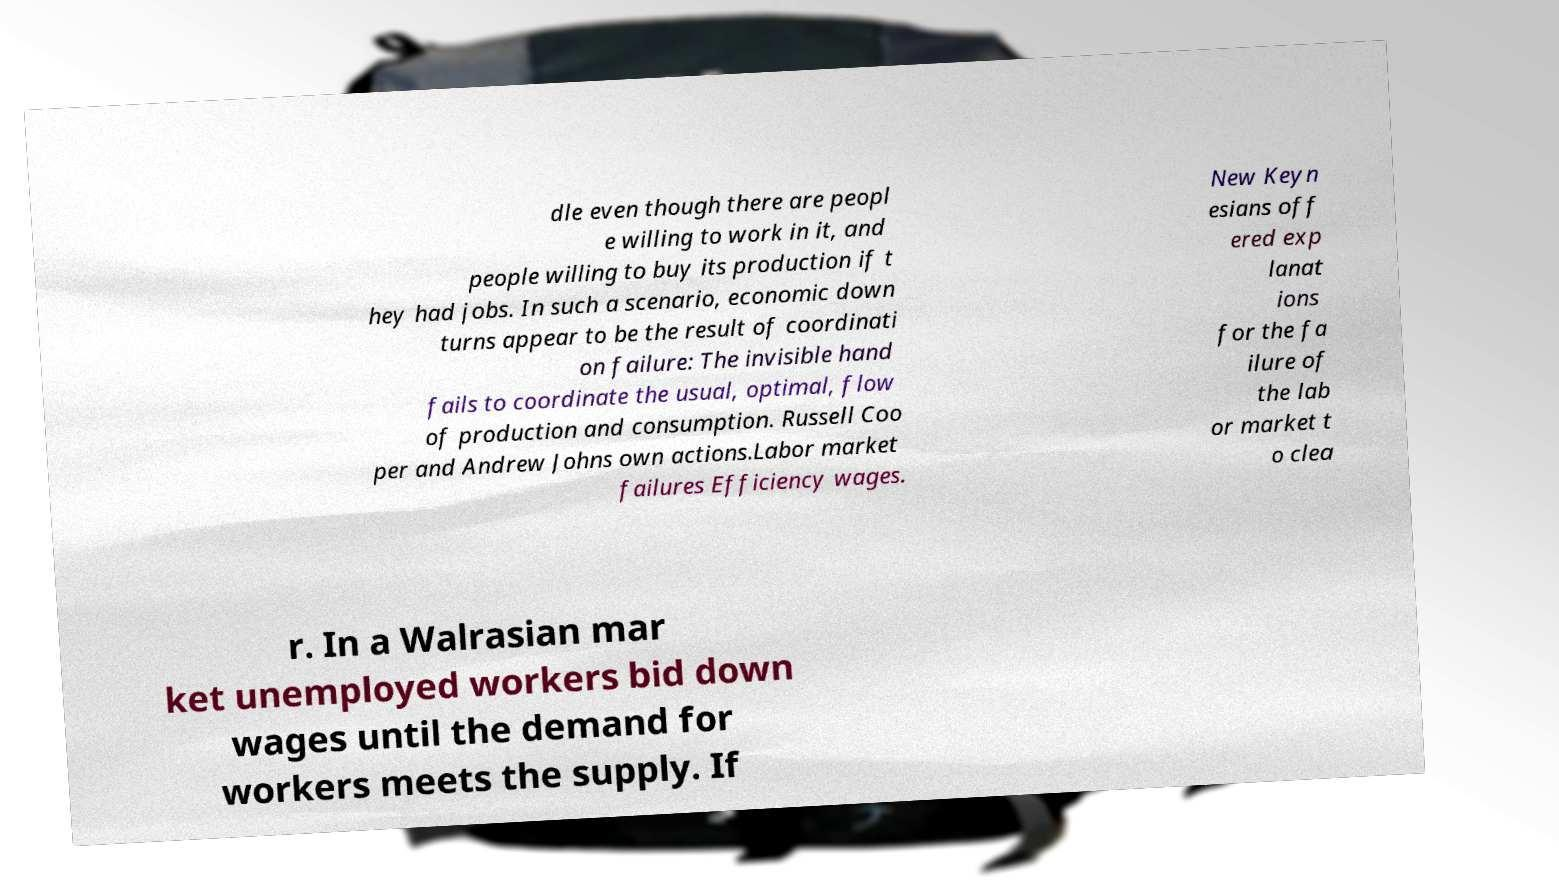Could you extract and type out the text from this image? dle even though there are peopl e willing to work in it, and people willing to buy its production if t hey had jobs. In such a scenario, economic down turns appear to be the result of coordinati on failure: The invisible hand fails to coordinate the usual, optimal, flow of production and consumption. Russell Coo per and Andrew Johns own actions.Labor market failures Efficiency wages. New Keyn esians off ered exp lanat ions for the fa ilure of the lab or market t o clea r. In a Walrasian mar ket unemployed workers bid down wages until the demand for workers meets the supply. If 